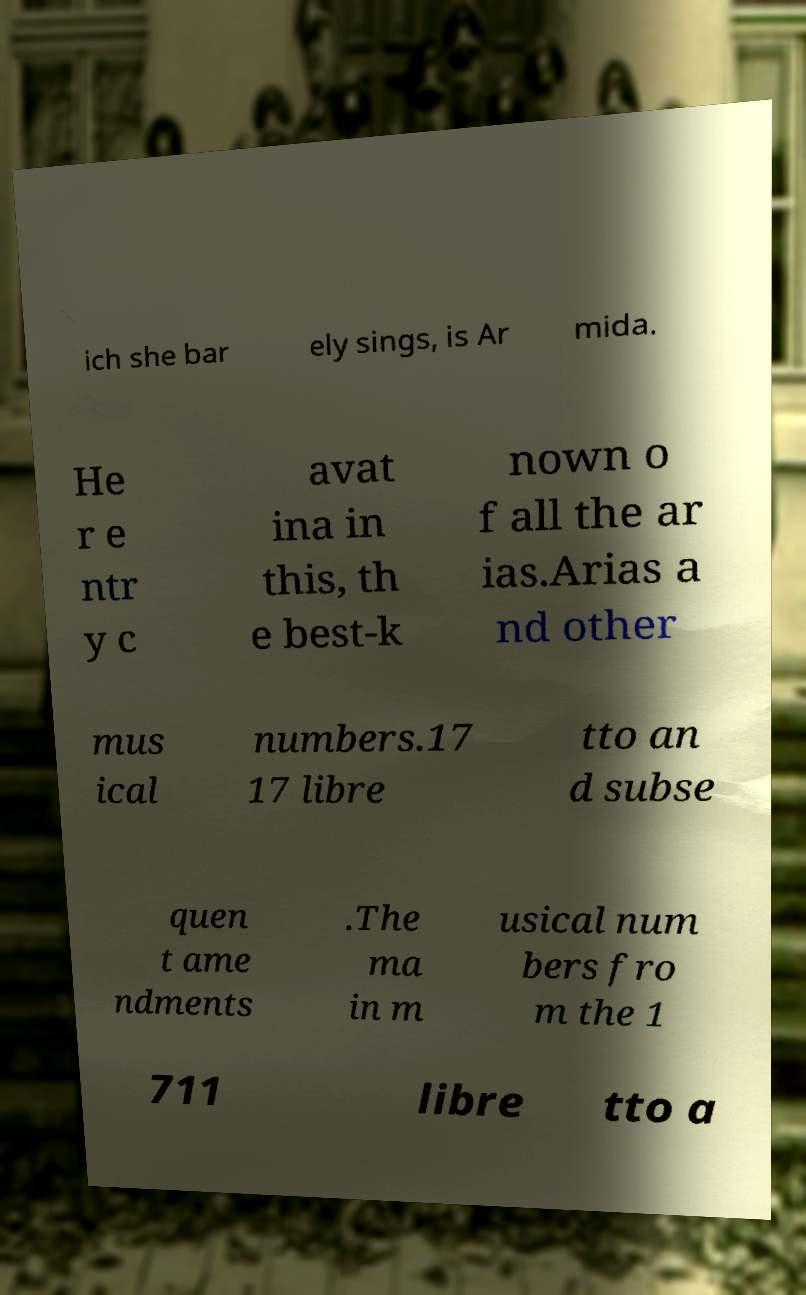Please identify and transcribe the text found in this image. ich she bar ely sings, is Ar mida. He r e ntr y c avat ina in this, th e best-k nown o f all the ar ias.Arias a nd other mus ical numbers.17 17 libre tto an d subse quen t ame ndments .The ma in m usical num bers fro m the 1 711 libre tto a 